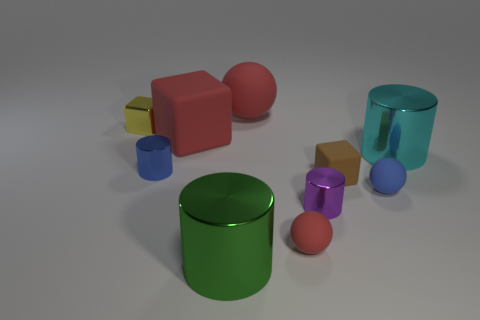There is a tiny thing that is the same color as the large matte cube; what is it made of?
Give a very brief answer. Rubber. What material is the big red ball?
Your answer should be compact. Rubber. Do the big cylinder in front of the cyan shiny cylinder and the cyan cylinder have the same material?
Provide a short and direct response. Yes. What is the shape of the small matte thing that is on the right side of the small brown matte cube?
Your answer should be very brief. Sphere. What is the material of the brown block that is the same size as the yellow metallic object?
Provide a succinct answer. Rubber. How many things are either large things that are behind the brown rubber block or big red things that are behind the yellow object?
Keep it short and to the point. 3. There is a purple object that is made of the same material as the green cylinder; what is its size?
Your response must be concise. Small. What number of shiny things are tiny gray cylinders or tiny blue things?
Offer a terse response. 1. How big is the brown cube?
Offer a very short reply. Small. Does the green cylinder have the same size as the yellow cube?
Make the answer very short. No. 